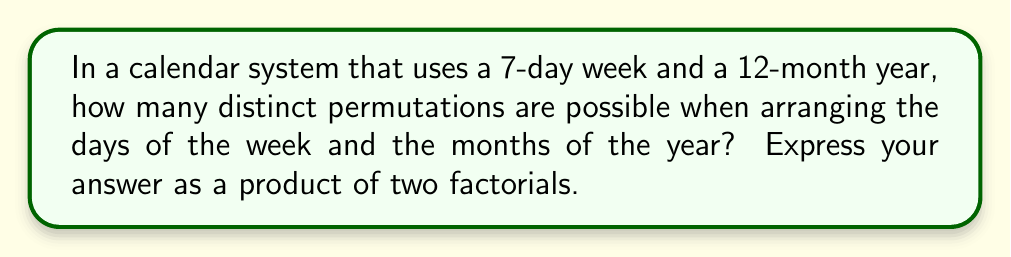Solve this math problem. To solve this problem, we need to consider the permutations of two separate sets: the days of the week and the months of the year.

1. For the days of the week:
   There are 7 days in a week, so we need to calculate the number of ways to arrange 7 distinct elements. This is given by 7!.

2. For the months of the year:
   There are 12 months in a year, so we need to calculate the number of ways to arrange 12 distinct elements. This is given by 12!.

3. Since the arrangement of days and months are independent of each other, we multiply these two values to get the total number of distinct permutations.

Therefore, the total number of distinct permutations is:

$$ 7! \times 12! $$

This can be written as a product of two factorials, which is the required form for the answer.

Note: This calculation assumes that each day of the week and each month of the year is treated as a distinct element, which is relevant for a technology blogger working with date and time handling libraries that might need to account for all possible arrangements.
Answer: $$ 7! \times 12! $$ 